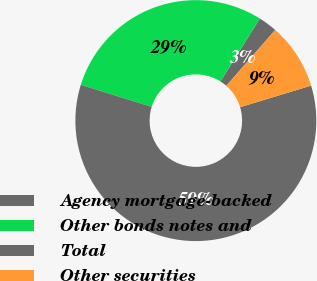Convert chart to OTSL. <chart><loc_0><loc_0><loc_500><loc_500><pie_chart><fcel>Agency mortgage-backed<fcel>Other bonds notes and<fcel>Total<fcel>Other securities<nl><fcel>2.53%<fcel>29.11%<fcel>59.49%<fcel>8.86%<nl></chart> 